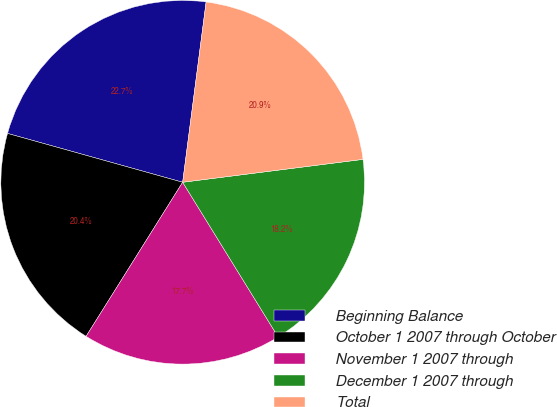Convert chart. <chart><loc_0><loc_0><loc_500><loc_500><pie_chart><fcel>Beginning Balance<fcel>October 1 2007 through October<fcel>November 1 2007 through<fcel>December 1 2007 through<fcel>Total<nl><fcel>22.73%<fcel>20.42%<fcel>17.71%<fcel>18.21%<fcel>20.93%<nl></chart> 